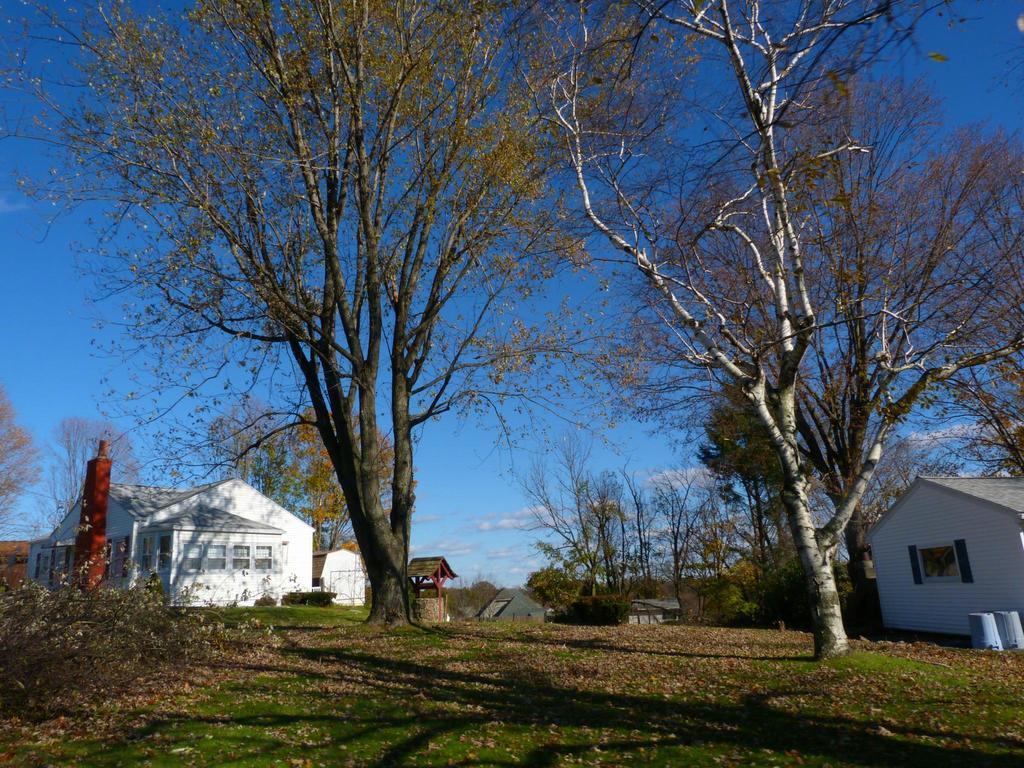Please provide a concise description of this image. This image consists of many trees. At the bottom, there is green grass on the ground. On the left and right, we can see small houses along with windows. At the top, there is sky in blue color. On the left, there are small plants on the ground. 